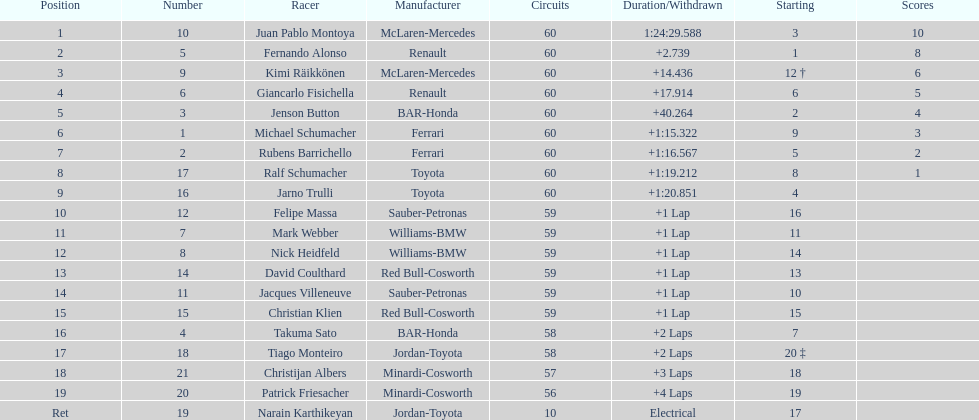How many drivers received points from the race? 8. 